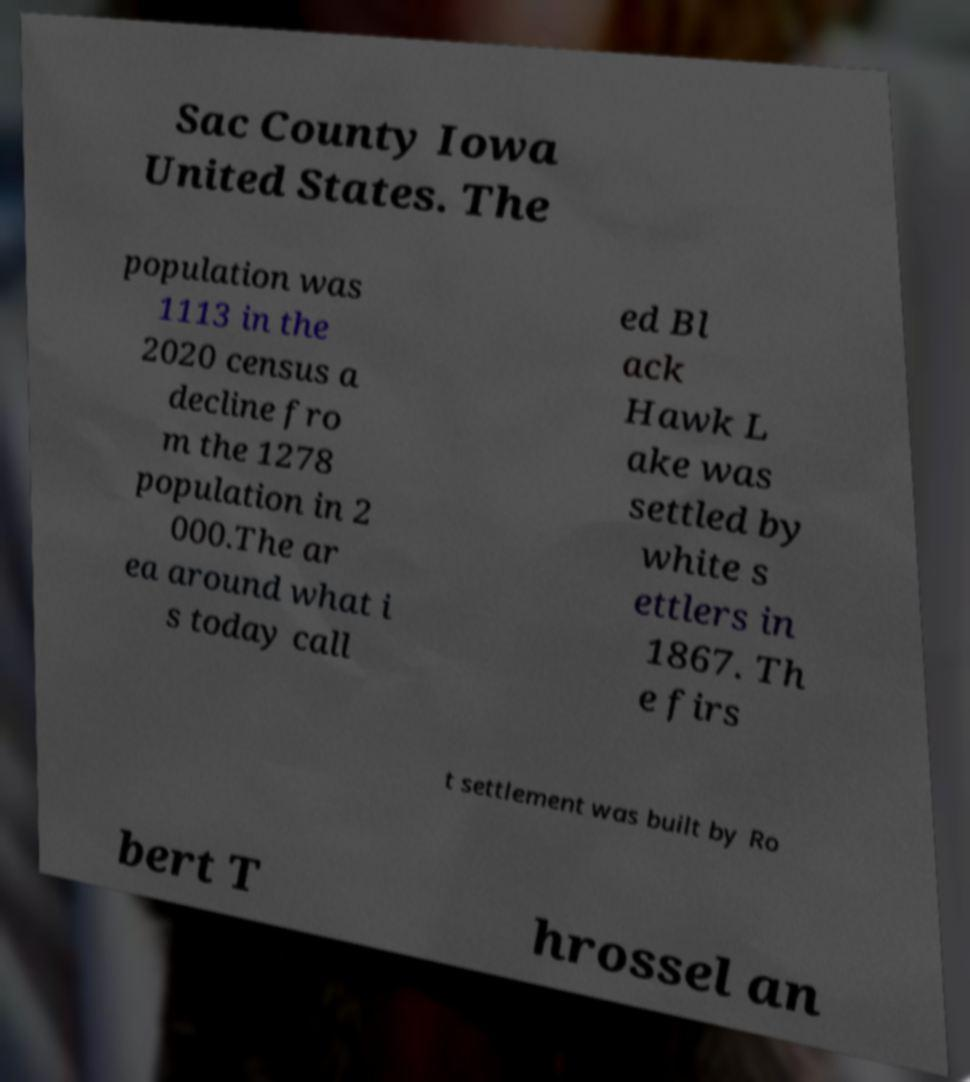Can you read and provide the text displayed in the image?This photo seems to have some interesting text. Can you extract and type it out for me? Sac County Iowa United States. The population was 1113 in the 2020 census a decline fro m the 1278 population in 2 000.The ar ea around what i s today call ed Bl ack Hawk L ake was settled by white s ettlers in 1867. Th e firs t settlement was built by Ro bert T hrossel an 